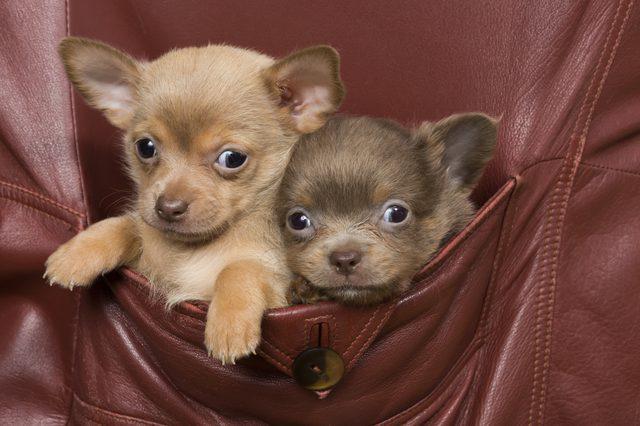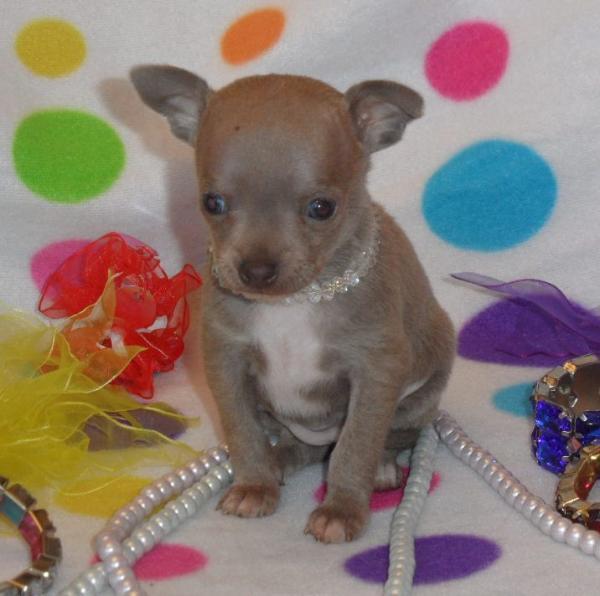The first image is the image on the left, the second image is the image on the right. Analyze the images presented: Is the assertion "A human hand is touching a small dog in one image." valid? Answer yes or no. No. The first image is the image on the left, the second image is the image on the right. Considering the images on both sides, is "There are two chihuahua puppies" valid? Answer yes or no. No. 